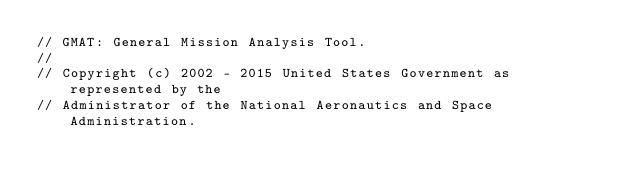<code> <loc_0><loc_0><loc_500><loc_500><_C++_>// GMAT: General Mission Analysis Tool.
//
// Copyright (c) 2002 - 2015 United States Government as represented by the
// Administrator of the National Aeronautics and Space Administration.</code> 